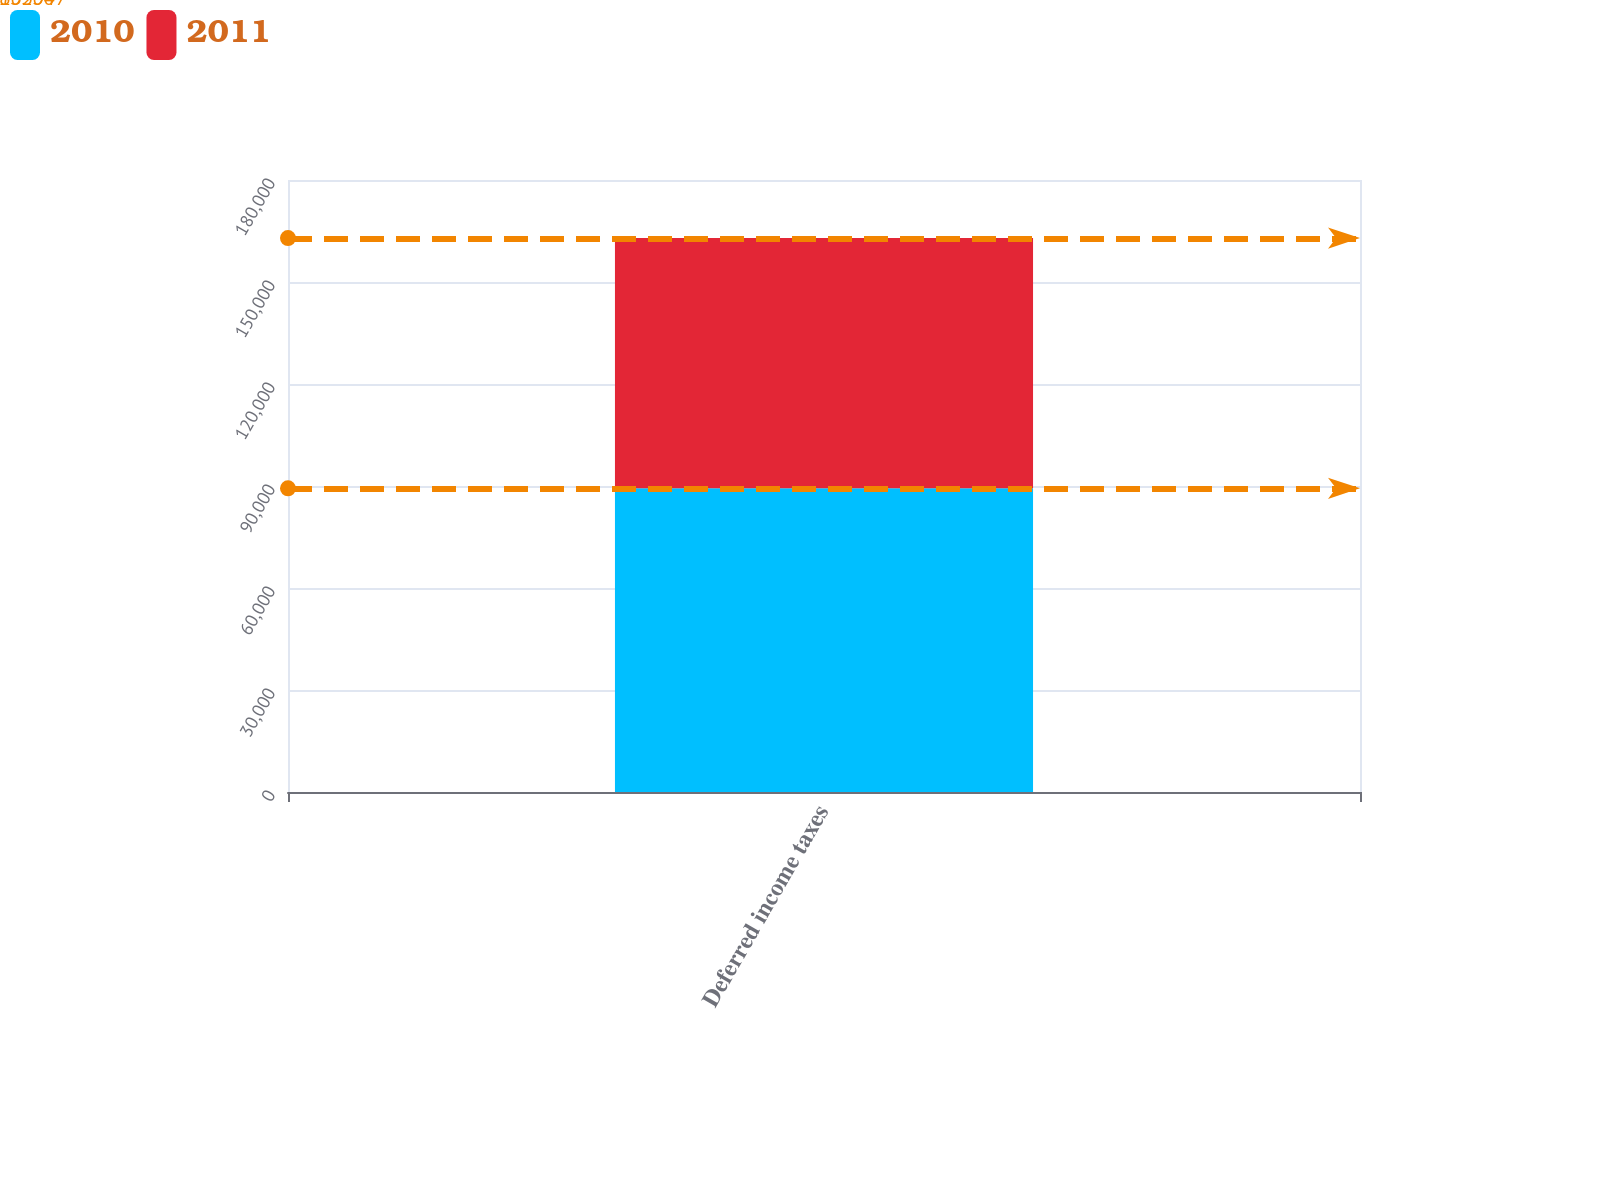<chart> <loc_0><loc_0><loc_500><loc_500><stacked_bar_chart><ecel><fcel>Deferred income taxes<nl><fcel>2010<fcel>89304<nl><fcel>2011<fcel>73603<nl></chart> 